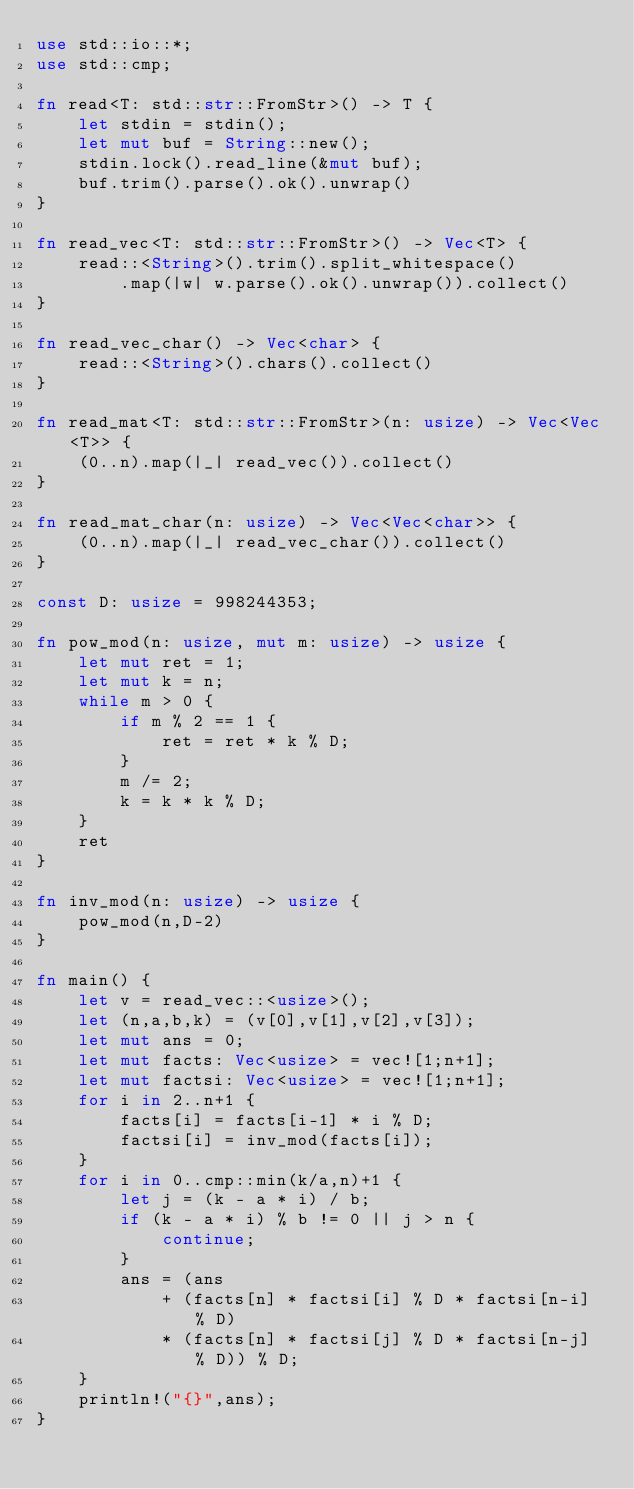<code> <loc_0><loc_0><loc_500><loc_500><_Rust_>use std::io::*;
use std::cmp;

fn read<T: std::str::FromStr>() -> T {
    let stdin = stdin();
    let mut buf = String::new();
	stdin.lock().read_line(&mut buf);
	buf.trim().parse().ok().unwrap()
}

fn read_vec<T: std::str::FromStr>() -> Vec<T> {
	read::<String>().trim().split_whitespace()
        .map(|w| w.parse().ok().unwrap()).collect()
}

fn read_vec_char() -> Vec<char> {
    read::<String>().chars().collect()
}

fn read_mat<T: std::str::FromStr>(n: usize) -> Vec<Vec<T>> {
    (0..n).map(|_| read_vec()).collect()
}

fn read_mat_char(n: usize) -> Vec<Vec<char>> {
    (0..n).map(|_| read_vec_char()).collect()
}

const D: usize = 998244353;

fn pow_mod(n: usize, mut m: usize) -> usize {
    let mut ret = 1;
    let mut k = n;
    while m > 0 {
        if m % 2 == 1 {
            ret = ret * k % D;
        }
        m /= 2;
        k = k * k % D;
    }
    ret
}

fn inv_mod(n: usize) -> usize {
    pow_mod(n,D-2)
}

fn main() {
    let v = read_vec::<usize>();
    let (n,a,b,k) = (v[0],v[1],v[2],v[3]);
    let mut ans = 0;
    let mut facts: Vec<usize> = vec![1;n+1];
    let mut factsi: Vec<usize> = vec![1;n+1];
    for i in 2..n+1 {
        facts[i] = facts[i-1] * i % D;
        factsi[i] = inv_mod(facts[i]);
    }
    for i in 0..cmp::min(k/a,n)+1 {
        let j = (k - a * i) / b;
        if (k - a * i) % b != 0 || j > n {
            continue;
        }
        ans = (ans
            + (facts[n] * factsi[i] % D * factsi[n-i] % D)
            * (facts[n] * factsi[j] % D * factsi[n-j] % D)) % D;
    }
    println!("{}",ans);
}
</code> 